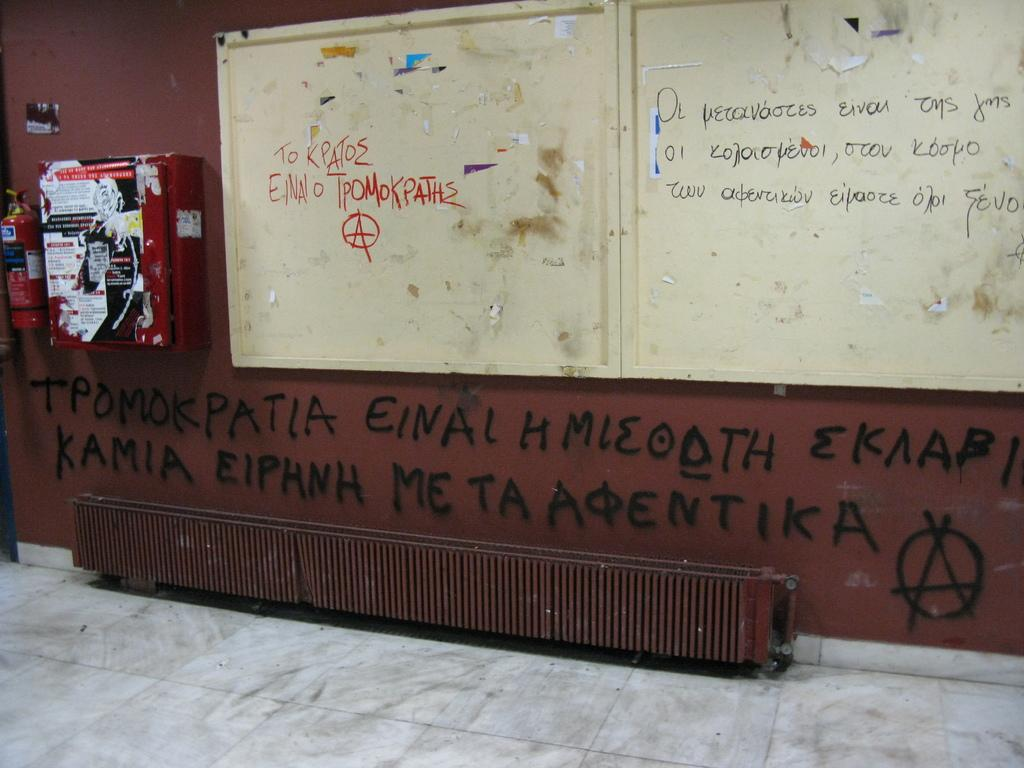<image>
Give a short and clear explanation of the subsequent image. Graffiti including the foreign word "tpomokpatia" is sprayed on a wall beneath a bulletin board. 